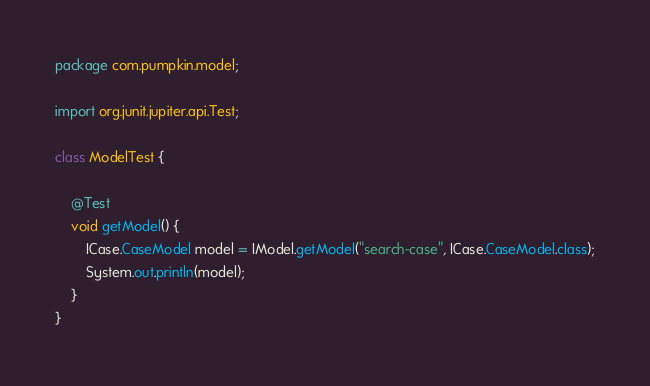Convert code to text. <code><loc_0><loc_0><loc_500><loc_500><_Java_>package com.pumpkin.model;

import org.junit.jupiter.api.Test;

class ModelTest {

    @Test
    void getModel() {
        ICase.CaseModel model = IModel.getModel("search-case", ICase.CaseModel.class);
        System.out.println(model);
    }
}</code> 